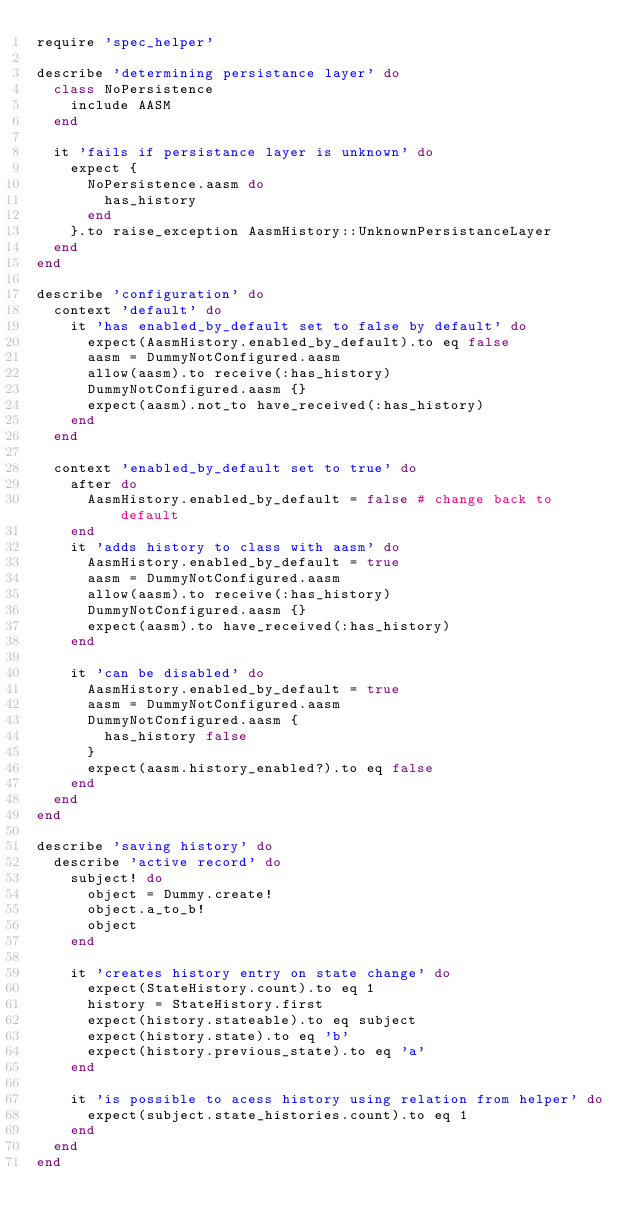Convert code to text. <code><loc_0><loc_0><loc_500><loc_500><_Ruby_>require 'spec_helper'

describe 'determining persistance layer' do
  class NoPersistence
    include AASM
  end

  it 'fails if persistance layer is unknown' do
    expect {
      NoPersistence.aasm do
        has_history
      end
    }.to raise_exception AasmHistory::UnknownPersistanceLayer
  end
end

describe 'configuration' do
  context 'default' do
    it 'has enabled_by_default set to false by default' do
      expect(AasmHistory.enabled_by_default).to eq false
      aasm = DummyNotConfigured.aasm
      allow(aasm).to receive(:has_history)
      DummyNotConfigured.aasm {}
      expect(aasm).not_to have_received(:has_history)
    end
  end

  context 'enabled_by_default set to true' do
    after do
      AasmHistory.enabled_by_default = false # change back to default
    end
    it 'adds history to class with aasm' do
      AasmHistory.enabled_by_default = true
      aasm = DummyNotConfigured.aasm
      allow(aasm).to receive(:has_history)
      DummyNotConfigured.aasm {}
      expect(aasm).to have_received(:has_history)
    end

    it 'can be disabled' do
      AasmHistory.enabled_by_default = true
      aasm = DummyNotConfigured.aasm
      DummyNotConfigured.aasm {
        has_history false
      }
      expect(aasm.history_enabled?).to eq false
    end
  end
end

describe 'saving history' do
  describe 'active record' do
    subject! do
      object = Dummy.create!
      object.a_to_b!
      object
    end

    it 'creates history entry on state change' do
      expect(StateHistory.count).to eq 1
      history = StateHistory.first
      expect(history.stateable).to eq subject
      expect(history.state).to eq 'b'
      expect(history.previous_state).to eq 'a'
    end

    it 'is possible to acess history using relation from helper' do
      expect(subject.state_histories.count).to eq 1
    end
  end
end</code> 